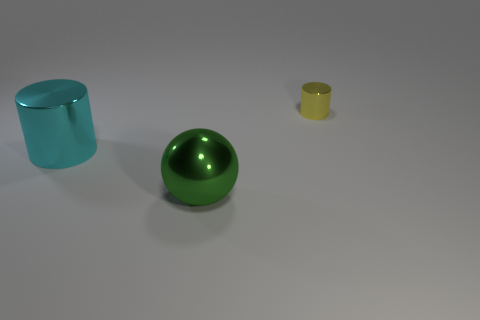How many shiny balls have the same size as the cyan metal cylinder?
Make the answer very short. 1. What number of other things are there of the same color as the shiny sphere?
Offer a very short reply. 0. Are there any other things that are the same size as the yellow cylinder?
Your response must be concise. No. There is a big thing to the left of the green ball; is it the same shape as the metallic thing right of the big green metal sphere?
Give a very brief answer. Yes. What shape is the other metallic object that is the same size as the cyan metal thing?
Make the answer very short. Sphere. Are there the same number of big cyan cylinders behind the cyan metal object and big cyan things on the left side of the ball?
Make the answer very short. No. Is there anything else that is the same shape as the green thing?
Keep it short and to the point. No. Does the large object that is on the left side of the big ball have the same material as the big green sphere?
Make the answer very short. Yes. There is a sphere that is the same size as the cyan metal object; what is it made of?
Provide a succinct answer. Metal. There is a yellow metal object; is its size the same as the thing that is in front of the large cyan metallic object?
Provide a short and direct response. No. 